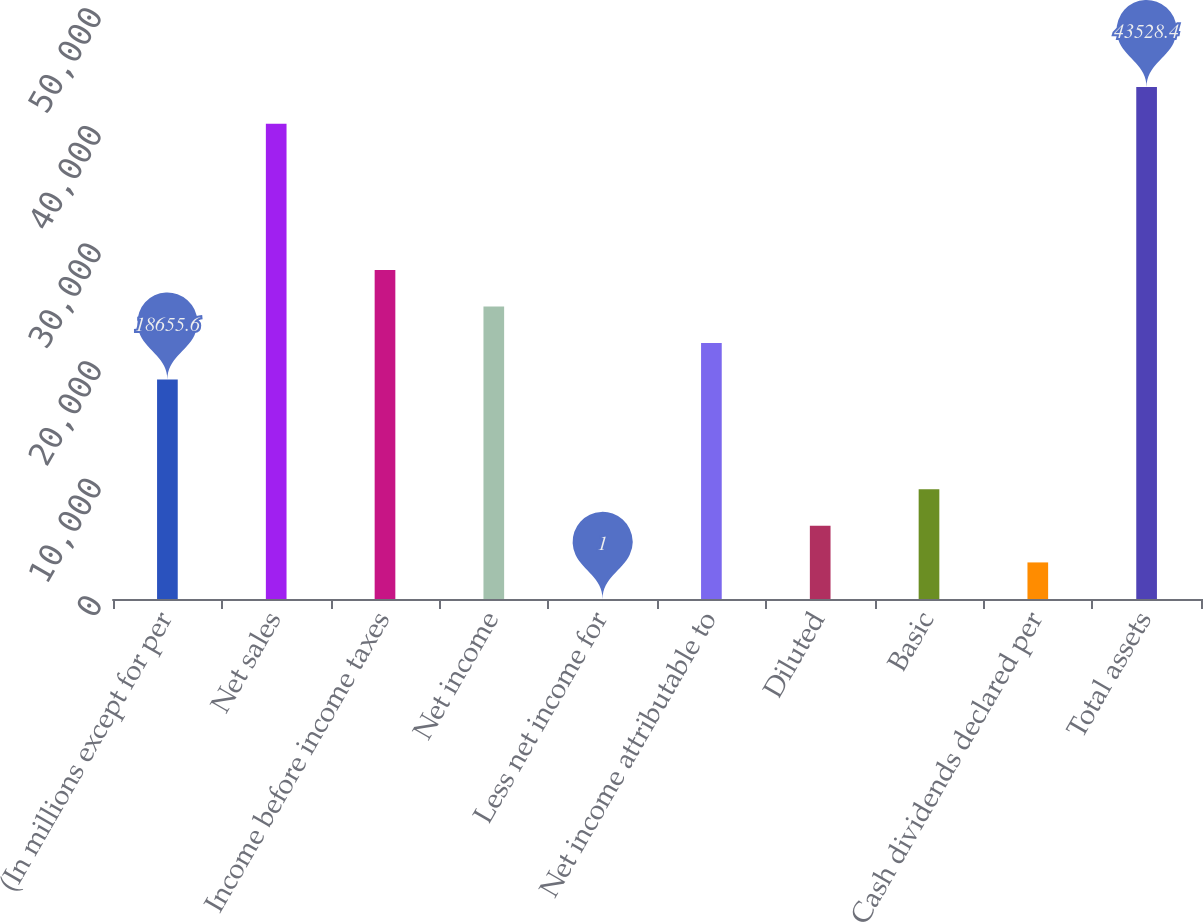<chart> <loc_0><loc_0><loc_500><loc_500><bar_chart><fcel>(In millions except for per<fcel>Net sales<fcel>Income before income taxes<fcel>Net income<fcel>Less net income for<fcel>Net income attributable to<fcel>Diluted<fcel>Basic<fcel>Cash dividends declared per<fcel>Total assets<nl><fcel>18655.6<fcel>40419.3<fcel>27982.9<fcel>24873.8<fcel>1<fcel>21764.7<fcel>6219.2<fcel>9328.3<fcel>3110.1<fcel>43528.4<nl></chart> 